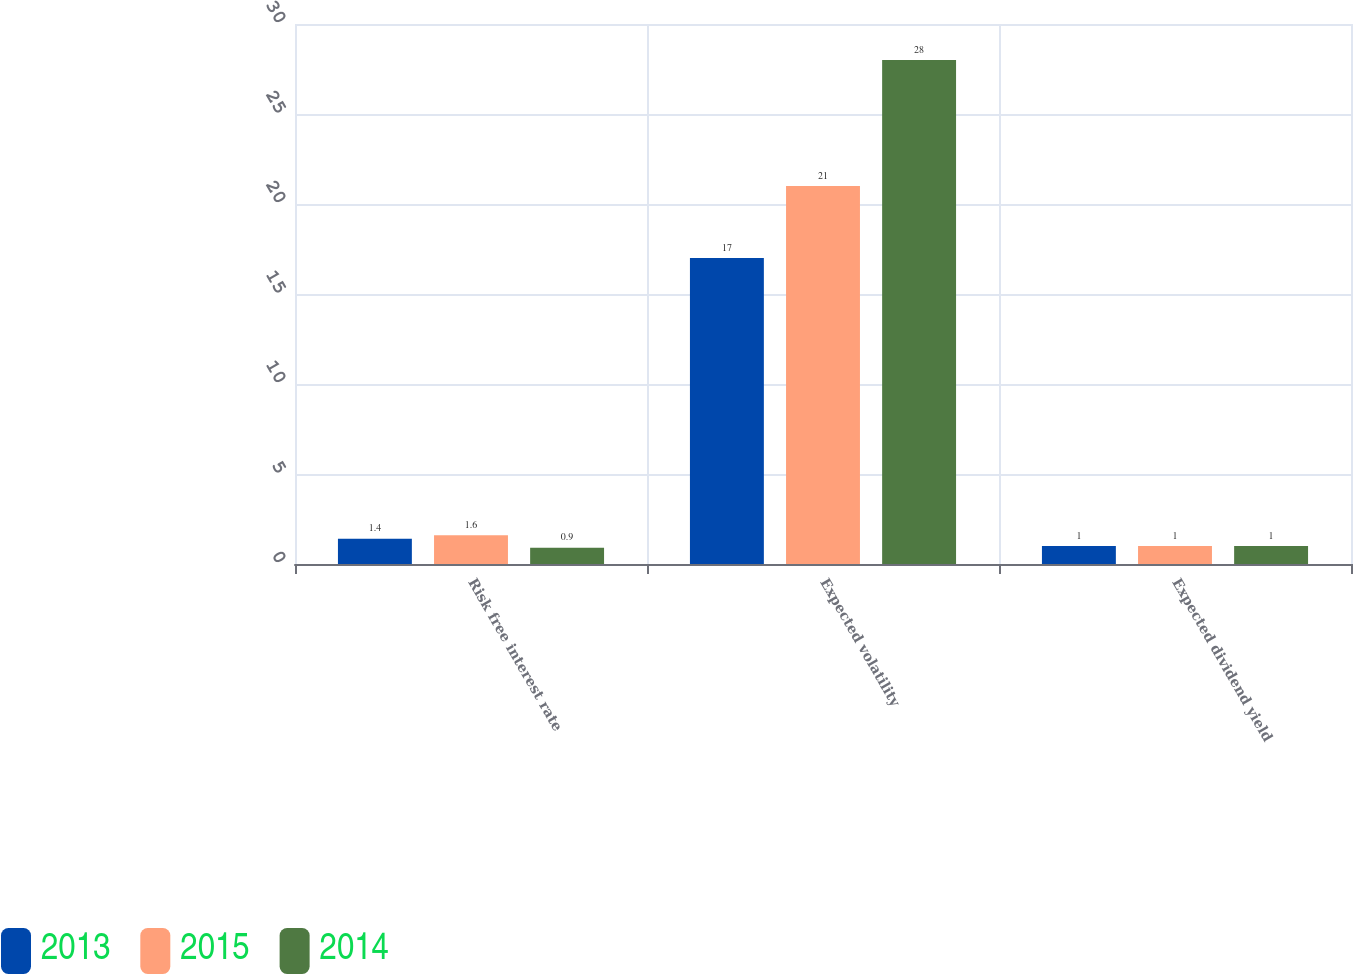Convert chart to OTSL. <chart><loc_0><loc_0><loc_500><loc_500><stacked_bar_chart><ecel><fcel>Risk free interest rate<fcel>Expected volatility<fcel>Expected dividend yield<nl><fcel>2013<fcel>1.4<fcel>17<fcel>1<nl><fcel>2015<fcel>1.6<fcel>21<fcel>1<nl><fcel>2014<fcel>0.9<fcel>28<fcel>1<nl></chart> 